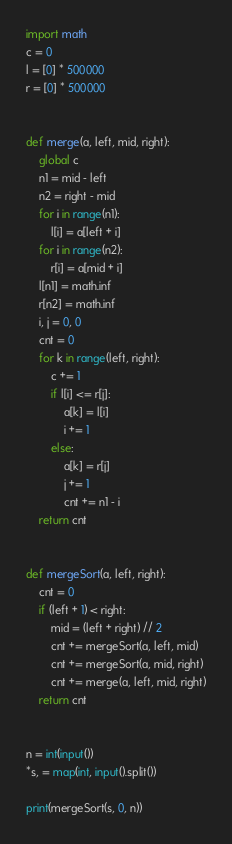Convert code to text. <code><loc_0><loc_0><loc_500><loc_500><_Python_>import math
c = 0
l = [0] * 500000
r = [0] * 500000


def merge(a, left, mid, right):
    global c
    n1 = mid - left
    n2 = right - mid
    for i in range(n1):
        l[i] = a[left + i]
    for i in range(n2):
        r[i] = a[mid + i]
    l[n1] = math.inf
    r[n2] = math.inf
    i, j = 0, 0
    cnt = 0
    for k in range(left, right):
        c += 1
        if l[i] <= r[j]:
            a[k] = l[i]
            i += 1
        else:
            a[k] = r[j]
            j += 1
            cnt += n1 - i
    return cnt


def mergeSort(a, left, right):
    cnt = 0
    if (left + 1) < right:
        mid = (left + right) // 2
        cnt += mergeSort(a, left, mid)
        cnt += mergeSort(a, mid, right)
        cnt += merge(a, left, mid, right)
    return cnt


n = int(input())
*s, = map(int, input().split())

print(mergeSort(s, 0, n))

</code> 